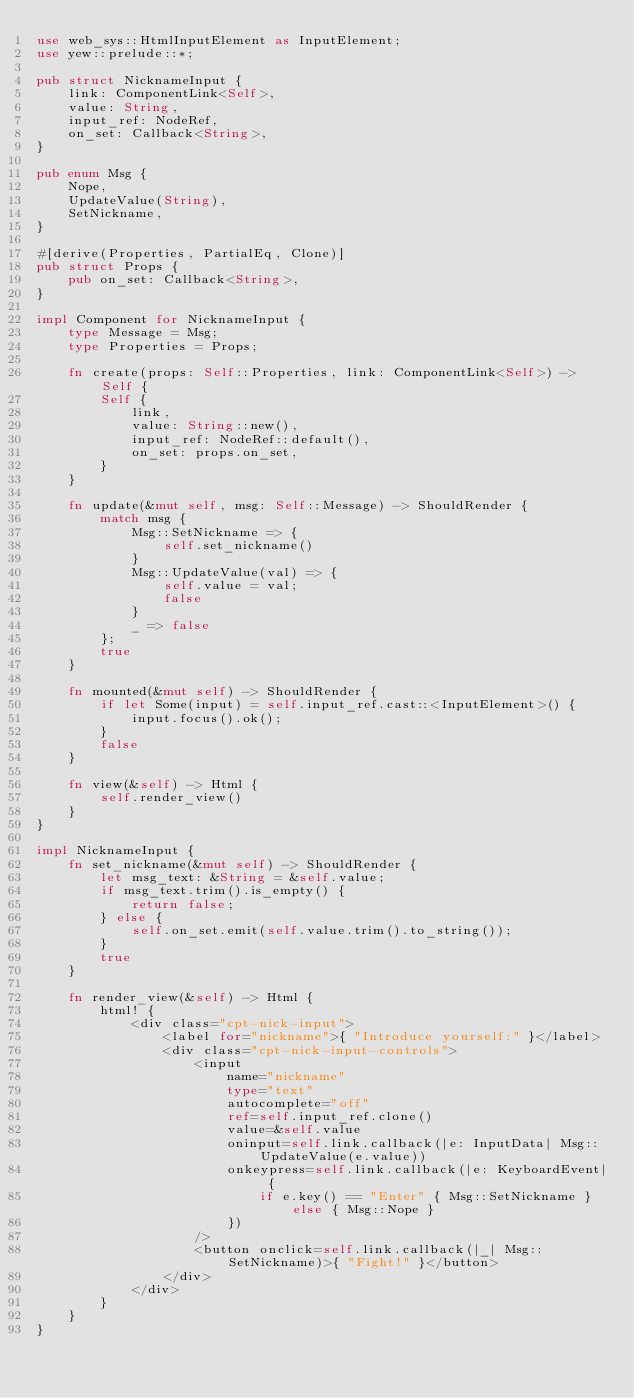<code> <loc_0><loc_0><loc_500><loc_500><_Rust_>use web_sys::HtmlInputElement as InputElement;
use yew::prelude::*;

pub struct NicknameInput {
    link: ComponentLink<Self>,
    value: String,
    input_ref: NodeRef,
    on_set: Callback<String>,
}

pub enum Msg {
    Nope,
    UpdateValue(String),
    SetNickname,
}

#[derive(Properties, PartialEq, Clone)]
pub struct Props {
    pub on_set: Callback<String>,
}

impl Component for NicknameInput {
    type Message = Msg;
    type Properties = Props;

    fn create(props: Self::Properties, link: ComponentLink<Self>) -> Self {
        Self {
            link,
            value: String::new(),
            input_ref: NodeRef::default(),
            on_set: props.on_set,
        }
    }

    fn update(&mut self, msg: Self::Message) -> ShouldRender {
        match msg {
            Msg::SetNickname => {
                self.set_nickname()
            }
            Msg::UpdateValue(val) => {
                self.value = val;
                false
            }
            _ => false
        };
        true
    }

    fn mounted(&mut self) -> ShouldRender {
        if let Some(input) = self.input_ref.cast::<InputElement>() {
            input.focus().ok();
        }
        false
    }

    fn view(&self) -> Html {
        self.render_view()
    }
}

impl NicknameInput {
    fn set_nickname(&mut self) -> ShouldRender {
        let msg_text: &String = &self.value;
        if msg_text.trim().is_empty() {
            return false;
        } else {
            self.on_set.emit(self.value.trim().to_string());
        }
        true
    }

    fn render_view(&self) -> Html {
        html! {
            <div class="cpt-nick-input">
                <label for="nickname">{ "Introduce yourself:" }</label>
                <div class="cpt-nick-input-controls">
                    <input 
                        name="nickname"
                        type="text"
                        autocomplete="off"
                        ref=self.input_ref.clone()
                        value=&self.value
                        oninput=self.link.callback(|e: InputData| Msg::UpdateValue(e.value))
                        onkeypress=self.link.callback(|e: KeyboardEvent| {
                            if e.key() == "Enter" { Msg::SetNickname } else { Msg::Nope }
                        })
                    />
                    <button onclick=self.link.callback(|_| Msg::SetNickname)>{ "Fight!" }</button>
                </div>
            </div>
        }
    }
}
</code> 